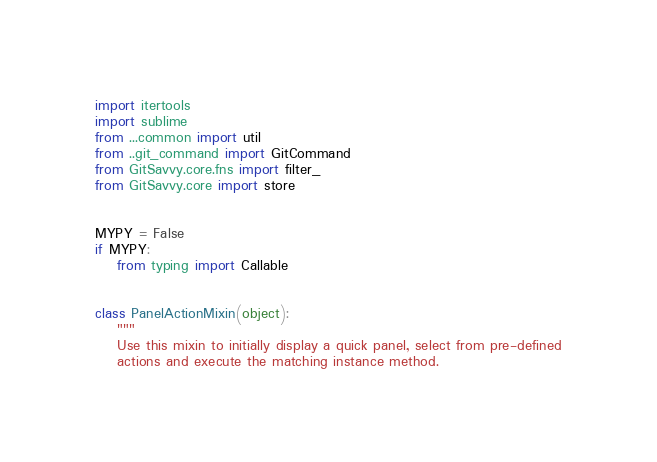Convert code to text. <code><loc_0><loc_0><loc_500><loc_500><_Python_>import itertools
import sublime
from ...common import util
from ..git_command import GitCommand
from GitSavvy.core.fns import filter_
from GitSavvy.core import store


MYPY = False
if MYPY:
    from typing import Callable


class PanelActionMixin(object):
    """
    Use this mixin to initially display a quick panel, select from pre-defined
    actions and execute the matching instance method.
</code> 